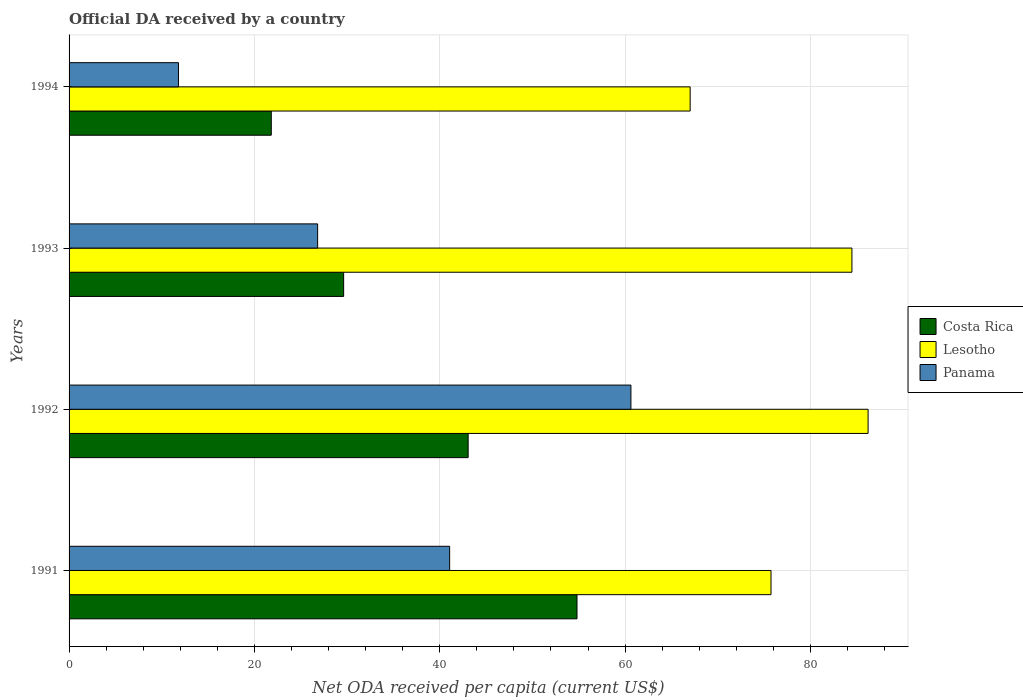What is the label of the 3rd group of bars from the top?
Your answer should be very brief. 1992. In how many cases, is the number of bars for a given year not equal to the number of legend labels?
Your answer should be compact. 0. What is the ODA received in in Lesotho in 1991?
Give a very brief answer. 75.75. Across all years, what is the maximum ODA received in in Costa Rica?
Ensure brevity in your answer.  54.81. Across all years, what is the minimum ODA received in in Lesotho?
Make the answer very short. 67.02. In which year was the ODA received in in Panama maximum?
Offer a terse response. 1992. What is the total ODA received in in Lesotho in the graph?
Provide a succinct answer. 313.47. What is the difference between the ODA received in in Costa Rica in 1991 and that in 1993?
Your response must be concise. 25.18. What is the difference between the ODA received in in Lesotho in 1993 and the ODA received in in Costa Rica in 1992?
Keep it short and to the point. 41.41. What is the average ODA received in in Costa Rica per year?
Your answer should be very brief. 37.33. In the year 1994, what is the difference between the ODA received in in Lesotho and ODA received in in Costa Rica?
Provide a succinct answer. 45.2. What is the ratio of the ODA received in in Panama in 1993 to that in 1994?
Your answer should be very brief. 2.27. Is the ODA received in in Costa Rica in 1992 less than that in 1993?
Offer a very short reply. No. Is the difference between the ODA received in in Lesotho in 1991 and 1992 greater than the difference between the ODA received in in Costa Rica in 1991 and 1992?
Give a very brief answer. No. What is the difference between the highest and the second highest ODA received in in Panama?
Ensure brevity in your answer.  19.56. What is the difference between the highest and the lowest ODA received in in Panama?
Give a very brief answer. 48.82. What does the 3rd bar from the top in 1991 represents?
Your answer should be very brief. Costa Rica. What does the 2nd bar from the bottom in 1993 represents?
Provide a succinct answer. Lesotho. Are all the bars in the graph horizontal?
Provide a succinct answer. Yes. How many years are there in the graph?
Make the answer very short. 4. Does the graph contain grids?
Keep it short and to the point. Yes. How are the legend labels stacked?
Provide a short and direct response. Vertical. What is the title of the graph?
Keep it short and to the point. Official DA received by a country. Does "Vanuatu" appear as one of the legend labels in the graph?
Provide a short and direct response. No. What is the label or title of the X-axis?
Offer a terse response. Net ODA received per capita (current US$). What is the Net ODA received per capita (current US$) of Costa Rica in 1991?
Your answer should be very brief. 54.81. What is the Net ODA received per capita (current US$) of Lesotho in 1991?
Provide a succinct answer. 75.75. What is the Net ODA received per capita (current US$) of Panama in 1991?
Provide a short and direct response. 41.07. What is the Net ODA received per capita (current US$) of Costa Rica in 1992?
Ensure brevity in your answer.  43.06. What is the Net ODA received per capita (current US$) of Lesotho in 1992?
Offer a very short reply. 86.22. What is the Net ODA received per capita (current US$) in Panama in 1992?
Keep it short and to the point. 60.63. What is the Net ODA received per capita (current US$) in Costa Rica in 1993?
Ensure brevity in your answer.  29.63. What is the Net ODA received per capita (current US$) in Lesotho in 1993?
Your response must be concise. 84.48. What is the Net ODA received per capita (current US$) of Panama in 1993?
Your response must be concise. 26.82. What is the Net ODA received per capita (current US$) in Costa Rica in 1994?
Provide a succinct answer. 21.82. What is the Net ODA received per capita (current US$) in Lesotho in 1994?
Your response must be concise. 67.02. What is the Net ODA received per capita (current US$) in Panama in 1994?
Give a very brief answer. 11.81. Across all years, what is the maximum Net ODA received per capita (current US$) in Costa Rica?
Provide a succinct answer. 54.81. Across all years, what is the maximum Net ODA received per capita (current US$) of Lesotho?
Ensure brevity in your answer.  86.22. Across all years, what is the maximum Net ODA received per capita (current US$) of Panama?
Offer a very short reply. 60.63. Across all years, what is the minimum Net ODA received per capita (current US$) in Costa Rica?
Give a very brief answer. 21.82. Across all years, what is the minimum Net ODA received per capita (current US$) of Lesotho?
Your response must be concise. 67.02. Across all years, what is the minimum Net ODA received per capita (current US$) in Panama?
Your answer should be very brief. 11.81. What is the total Net ODA received per capita (current US$) of Costa Rica in the graph?
Provide a succinct answer. 149.32. What is the total Net ODA received per capita (current US$) in Lesotho in the graph?
Keep it short and to the point. 313.47. What is the total Net ODA received per capita (current US$) of Panama in the graph?
Keep it short and to the point. 140.32. What is the difference between the Net ODA received per capita (current US$) of Costa Rica in 1991 and that in 1992?
Make the answer very short. 11.75. What is the difference between the Net ODA received per capita (current US$) of Lesotho in 1991 and that in 1992?
Your answer should be very brief. -10.47. What is the difference between the Net ODA received per capita (current US$) in Panama in 1991 and that in 1992?
Give a very brief answer. -19.56. What is the difference between the Net ODA received per capita (current US$) of Costa Rica in 1991 and that in 1993?
Keep it short and to the point. 25.18. What is the difference between the Net ODA received per capita (current US$) in Lesotho in 1991 and that in 1993?
Your response must be concise. -8.73. What is the difference between the Net ODA received per capita (current US$) in Panama in 1991 and that in 1993?
Offer a terse response. 14.25. What is the difference between the Net ODA received per capita (current US$) of Costa Rica in 1991 and that in 1994?
Keep it short and to the point. 32.99. What is the difference between the Net ODA received per capita (current US$) in Lesotho in 1991 and that in 1994?
Your response must be concise. 8.73. What is the difference between the Net ODA received per capita (current US$) of Panama in 1991 and that in 1994?
Give a very brief answer. 29.26. What is the difference between the Net ODA received per capita (current US$) of Costa Rica in 1992 and that in 1993?
Your answer should be compact. 13.44. What is the difference between the Net ODA received per capita (current US$) in Lesotho in 1992 and that in 1993?
Make the answer very short. 1.74. What is the difference between the Net ODA received per capita (current US$) of Panama in 1992 and that in 1993?
Offer a terse response. 33.81. What is the difference between the Net ODA received per capita (current US$) of Costa Rica in 1992 and that in 1994?
Your answer should be compact. 21.24. What is the difference between the Net ODA received per capita (current US$) of Lesotho in 1992 and that in 1994?
Keep it short and to the point. 19.2. What is the difference between the Net ODA received per capita (current US$) of Panama in 1992 and that in 1994?
Keep it short and to the point. 48.82. What is the difference between the Net ODA received per capita (current US$) in Costa Rica in 1993 and that in 1994?
Give a very brief answer. 7.81. What is the difference between the Net ODA received per capita (current US$) of Lesotho in 1993 and that in 1994?
Provide a succinct answer. 17.46. What is the difference between the Net ODA received per capita (current US$) of Panama in 1993 and that in 1994?
Give a very brief answer. 15.02. What is the difference between the Net ODA received per capita (current US$) in Costa Rica in 1991 and the Net ODA received per capita (current US$) in Lesotho in 1992?
Offer a very short reply. -31.41. What is the difference between the Net ODA received per capita (current US$) in Costa Rica in 1991 and the Net ODA received per capita (current US$) in Panama in 1992?
Provide a short and direct response. -5.82. What is the difference between the Net ODA received per capita (current US$) of Lesotho in 1991 and the Net ODA received per capita (current US$) of Panama in 1992?
Provide a succinct answer. 15.12. What is the difference between the Net ODA received per capita (current US$) in Costa Rica in 1991 and the Net ODA received per capita (current US$) in Lesotho in 1993?
Ensure brevity in your answer.  -29.67. What is the difference between the Net ODA received per capita (current US$) of Costa Rica in 1991 and the Net ODA received per capita (current US$) of Panama in 1993?
Keep it short and to the point. 27.99. What is the difference between the Net ODA received per capita (current US$) of Lesotho in 1991 and the Net ODA received per capita (current US$) of Panama in 1993?
Provide a succinct answer. 48.93. What is the difference between the Net ODA received per capita (current US$) of Costa Rica in 1991 and the Net ODA received per capita (current US$) of Lesotho in 1994?
Give a very brief answer. -12.21. What is the difference between the Net ODA received per capita (current US$) in Costa Rica in 1991 and the Net ODA received per capita (current US$) in Panama in 1994?
Give a very brief answer. 43.01. What is the difference between the Net ODA received per capita (current US$) of Lesotho in 1991 and the Net ODA received per capita (current US$) of Panama in 1994?
Provide a succinct answer. 63.94. What is the difference between the Net ODA received per capita (current US$) of Costa Rica in 1992 and the Net ODA received per capita (current US$) of Lesotho in 1993?
Your answer should be compact. -41.41. What is the difference between the Net ODA received per capita (current US$) of Costa Rica in 1992 and the Net ODA received per capita (current US$) of Panama in 1993?
Ensure brevity in your answer.  16.24. What is the difference between the Net ODA received per capita (current US$) in Lesotho in 1992 and the Net ODA received per capita (current US$) in Panama in 1993?
Offer a terse response. 59.4. What is the difference between the Net ODA received per capita (current US$) of Costa Rica in 1992 and the Net ODA received per capita (current US$) of Lesotho in 1994?
Make the answer very short. -23.96. What is the difference between the Net ODA received per capita (current US$) in Costa Rica in 1992 and the Net ODA received per capita (current US$) in Panama in 1994?
Provide a succinct answer. 31.26. What is the difference between the Net ODA received per capita (current US$) in Lesotho in 1992 and the Net ODA received per capita (current US$) in Panama in 1994?
Your answer should be compact. 74.42. What is the difference between the Net ODA received per capita (current US$) of Costa Rica in 1993 and the Net ODA received per capita (current US$) of Lesotho in 1994?
Your answer should be compact. -37.39. What is the difference between the Net ODA received per capita (current US$) of Costa Rica in 1993 and the Net ODA received per capita (current US$) of Panama in 1994?
Provide a short and direct response. 17.82. What is the difference between the Net ODA received per capita (current US$) in Lesotho in 1993 and the Net ODA received per capita (current US$) in Panama in 1994?
Your response must be concise. 72.67. What is the average Net ODA received per capita (current US$) in Costa Rica per year?
Keep it short and to the point. 37.33. What is the average Net ODA received per capita (current US$) of Lesotho per year?
Your answer should be compact. 78.37. What is the average Net ODA received per capita (current US$) of Panama per year?
Make the answer very short. 35.08. In the year 1991, what is the difference between the Net ODA received per capita (current US$) in Costa Rica and Net ODA received per capita (current US$) in Lesotho?
Offer a terse response. -20.94. In the year 1991, what is the difference between the Net ODA received per capita (current US$) in Costa Rica and Net ODA received per capita (current US$) in Panama?
Provide a short and direct response. 13.74. In the year 1991, what is the difference between the Net ODA received per capita (current US$) of Lesotho and Net ODA received per capita (current US$) of Panama?
Give a very brief answer. 34.68. In the year 1992, what is the difference between the Net ODA received per capita (current US$) of Costa Rica and Net ODA received per capita (current US$) of Lesotho?
Give a very brief answer. -43.16. In the year 1992, what is the difference between the Net ODA received per capita (current US$) in Costa Rica and Net ODA received per capita (current US$) in Panama?
Make the answer very short. -17.56. In the year 1992, what is the difference between the Net ODA received per capita (current US$) in Lesotho and Net ODA received per capita (current US$) in Panama?
Your response must be concise. 25.59. In the year 1993, what is the difference between the Net ODA received per capita (current US$) in Costa Rica and Net ODA received per capita (current US$) in Lesotho?
Offer a terse response. -54.85. In the year 1993, what is the difference between the Net ODA received per capita (current US$) in Costa Rica and Net ODA received per capita (current US$) in Panama?
Offer a very short reply. 2.81. In the year 1993, what is the difference between the Net ODA received per capita (current US$) in Lesotho and Net ODA received per capita (current US$) in Panama?
Make the answer very short. 57.66. In the year 1994, what is the difference between the Net ODA received per capita (current US$) of Costa Rica and Net ODA received per capita (current US$) of Lesotho?
Offer a very short reply. -45.2. In the year 1994, what is the difference between the Net ODA received per capita (current US$) of Costa Rica and Net ODA received per capita (current US$) of Panama?
Give a very brief answer. 10.02. In the year 1994, what is the difference between the Net ODA received per capita (current US$) in Lesotho and Net ODA received per capita (current US$) in Panama?
Your response must be concise. 55.22. What is the ratio of the Net ODA received per capita (current US$) of Costa Rica in 1991 to that in 1992?
Offer a very short reply. 1.27. What is the ratio of the Net ODA received per capita (current US$) of Lesotho in 1991 to that in 1992?
Your response must be concise. 0.88. What is the ratio of the Net ODA received per capita (current US$) in Panama in 1991 to that in 1992?
Offer a terse response. 0.68. What is the ratio of the Net ODA received per capita (current US$) of Costa Rica in 1991 to that in 1993?
Ensure brevity in your answer.  1.85. What is the ratio of the Net ODA received per capita (current US$) of Lesotho in 1991 to that in 1993?
Ensure brevity in your answer.  0.9. What is the ratio of the Net ODA received per capita (current US$) of Panama in 1991 to that in 1993?
Your answer should be very brief. 1.53. What is the ratio of the Net ODA received per capita (current US$) in Costa Rica in 1991 to that in 1994?
Give a very brief answer. 2.51. What is the ratio of the Net ODA received per capita (current US$) in Lesotho in 1991 to that in 1994?
Offer a terse response. 1.13. What is the ratio of the Net ODA received per capita (current US$) in Panama in 1991 to that in 1994?
Offer a very short reply. 3.48. What is the ratio of the Net ODA received per capita (current US$) of Costa Rica in 1992 to that in 1993?
Offer a very short reply. 1.45. What is the ratio of the Net ODA received per capita (current US$) of Lesotho in 1992 to that in 1993?
Make the answer very short. 1.02. What is the ratio of the Net ODA received per capita (current US$) of Panama in 1992 to that in 1993?
Offer a very short reply. 2.26. What is the ratio of the Net ODA received per capita (current US$) in Costa Rica in 1992 to that in 1994?
Offer a terse response. 1.97. What is the ratio of the Net ODA received per capita (current US$) of Lesotho in 1992 to that in 1994?
Give a very brief answer. 1.29. What is the ratio of the Net ODA received per capita (current US$) of Panama in 1992 to that in 1994?
Offer a terse response. 5.14. What is the ratio of the Net ODA received per capita (current US$) in Costa Rica in 1993 to that in 1994?
Ensure brevity in your answer.  1.36. What is the ratio of the Net ODA received per capita (current US$) in Lesotho in 1993 to that in 1994?
Your response must be concise. 1.26. What is the ratio of the Net ODA received per capita (current US$) of Panama in 1993 to that in 1994?
Provide a short and direct response. 2.27. What is the difference between the highest and the second highest Net ODA received per capita (current US$) in Costa Rica?
Provide a short and direct response. 11.75. What is the difference between the highest and the second highest Net ODA received per capita (current US$) of Lesotho?
Make the answer very short. 1.74. What is the difference between the highest and the second highest Net ODA received per capita (current US$) of Panama?
Your answer should be compact. 19.56. What is the difference between the highest and the lowest Net ODA received per capita (current US$) of Costa Rica?
Offer a terse response. 32.99. What is the difference between the highest and the lowest Net ODA received per capita (current US$) in Lesotho?
Your answer should be compact. 19.2. What is the difference between the highest and the lowest Net ODA received per capita (current US$) of Panama?
Your answer should be very brief. 48.82. 